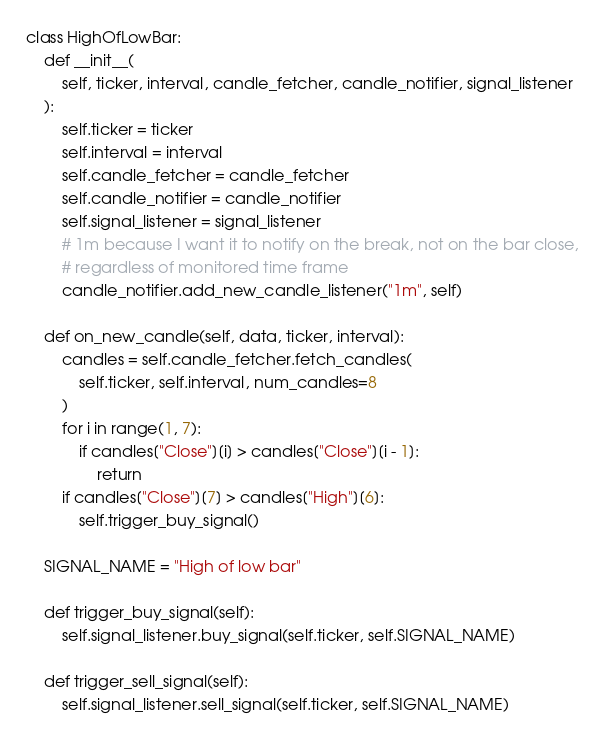Convert code to text. <code><loc_0><loc_0><loc_500><loc_500><_Python_>class HighOfLowBar:
    def __init__(
        self, ticker, interval, candle_fetcher, candle_notifier, signal_listener
    ):
        self.ticker = ticker
        self.interval = interval
        self.candle_fetcher = candle_fetcher
        self.candle_notifier = candle_notifier
        self.signal_listener = signal_listener
        # 1m because I want it to notify on the break, not on the bar close,
        # regardless of monitored time frame
        candle_notifier.add_new_candle_listener("1m", self)

    def on_new_candle(self, data, ticker, interval):
        candles = self.candle_fetcher.fetch_candles(
            self.ticker, self.interval, num_candles=8
        )
        for i in range(1, 7):
            if candles["Close"][i] > candles["Close"][i - 1]:
                return
        if candles["Close"][7] > candles["High"][6]:
            self.trigger_buy_signal()

    SIGNAL_NAME = "High of low bar"

    def trigger_buy_signal(self):
        self.signal_listener.buy_signal(self.ticker, self.SIGNAL_NAME)

    def trigger_sell_signal(self):
        self.signal_listener.sell_signal(self.ticker, self.SIGNAL_NAME)
</code> 